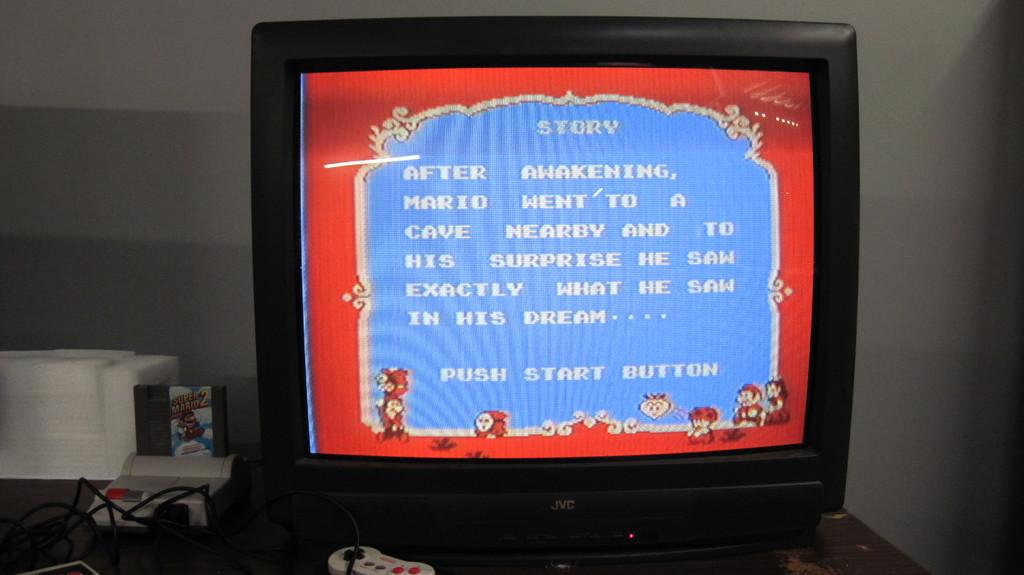What button do you push to continue?
Keep it short and to the point. Start. 